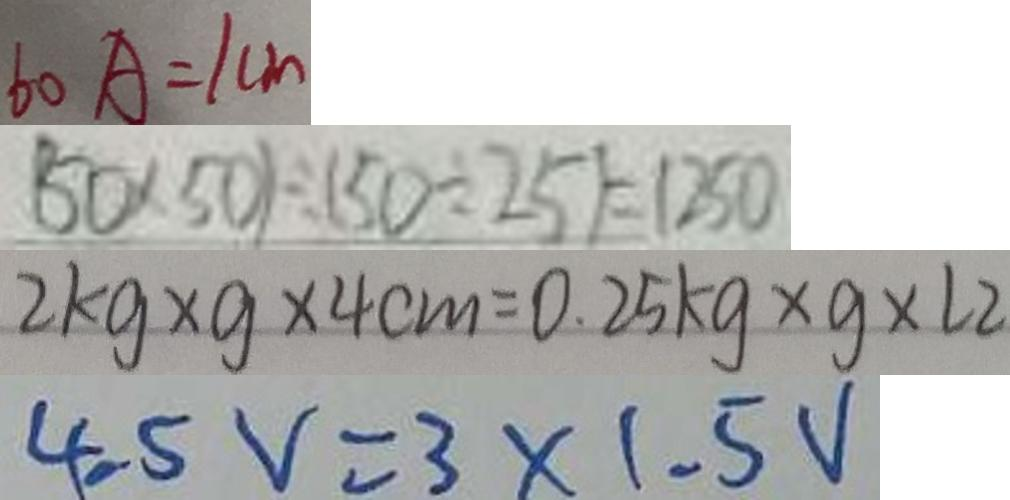<formula> <loc_0><loc_0><loc_500><loc_500>6 0 A = 1 c m 
 ( 5 0 \times 5 0 ) \div ( 5 0 \div 2 5 ) = 1 2 5 0 
 2 k g \times g \times 4 c m = 0 . 2 5 k g \times g \times \angle 2 
 4 . 5 V = 3 \times 1 . 5 V</formula> 